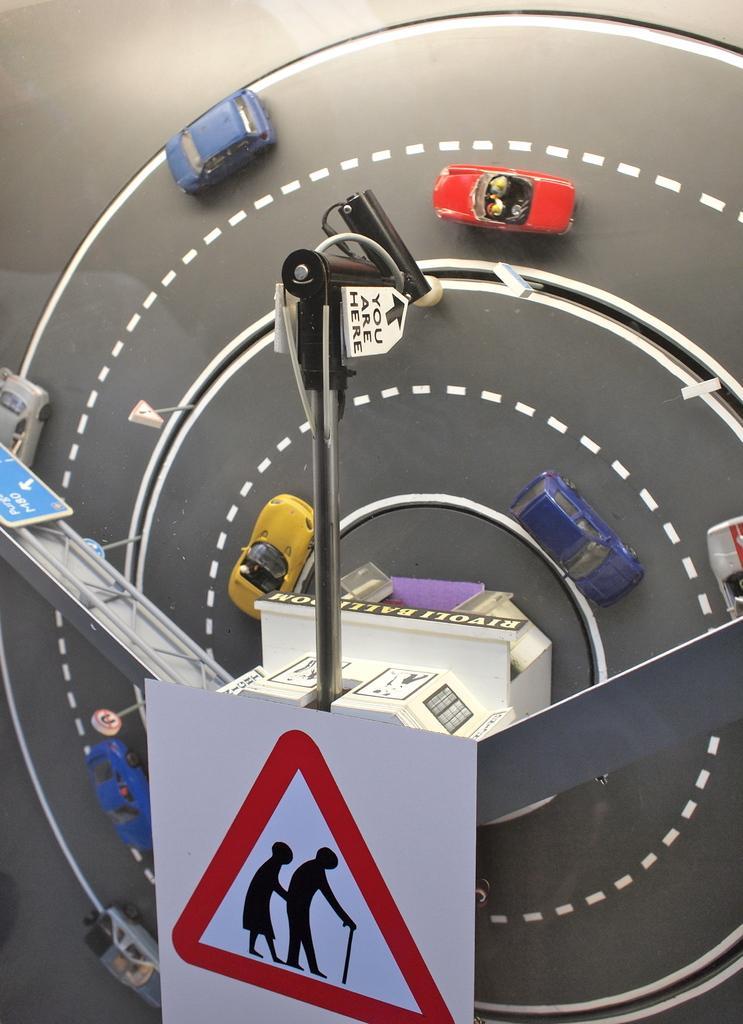Can you describe this image briefly? In this image I can see the miniature of few vehicles on the road. These vehicles are colorful and I can see the pole and the board. 